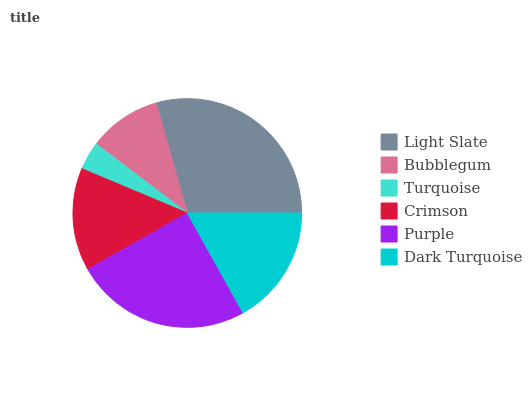Is Turquoise the minimum?
Answer yes or no. Yes. Is Light Slate the maximum?
Answer yes or no. Yes. Is Bubblegum the minimum?
Answer yes or no. No. Is Bubblegum the maximum?
Answer yes or no. No. Is Light Slate greater than Bubblegum?
Answer yes or no. Yes. Is Bubblegum less than Light Slate?
Answer yes or no. Yes. Is Bubblegum greater than Light Slate?
Answer yes or no. No. Is Light Slate less than Bubblegum?
Answer yes or no. No. Is Dark Turquoise the high median?
Answer yes or no. Yes. Is Crimson the low median?
Answer yes or no. Yes. Is Turquoise the high median?
Answer yes or no. No. Is Turquoise the low median?
Answer yes or no. No. 